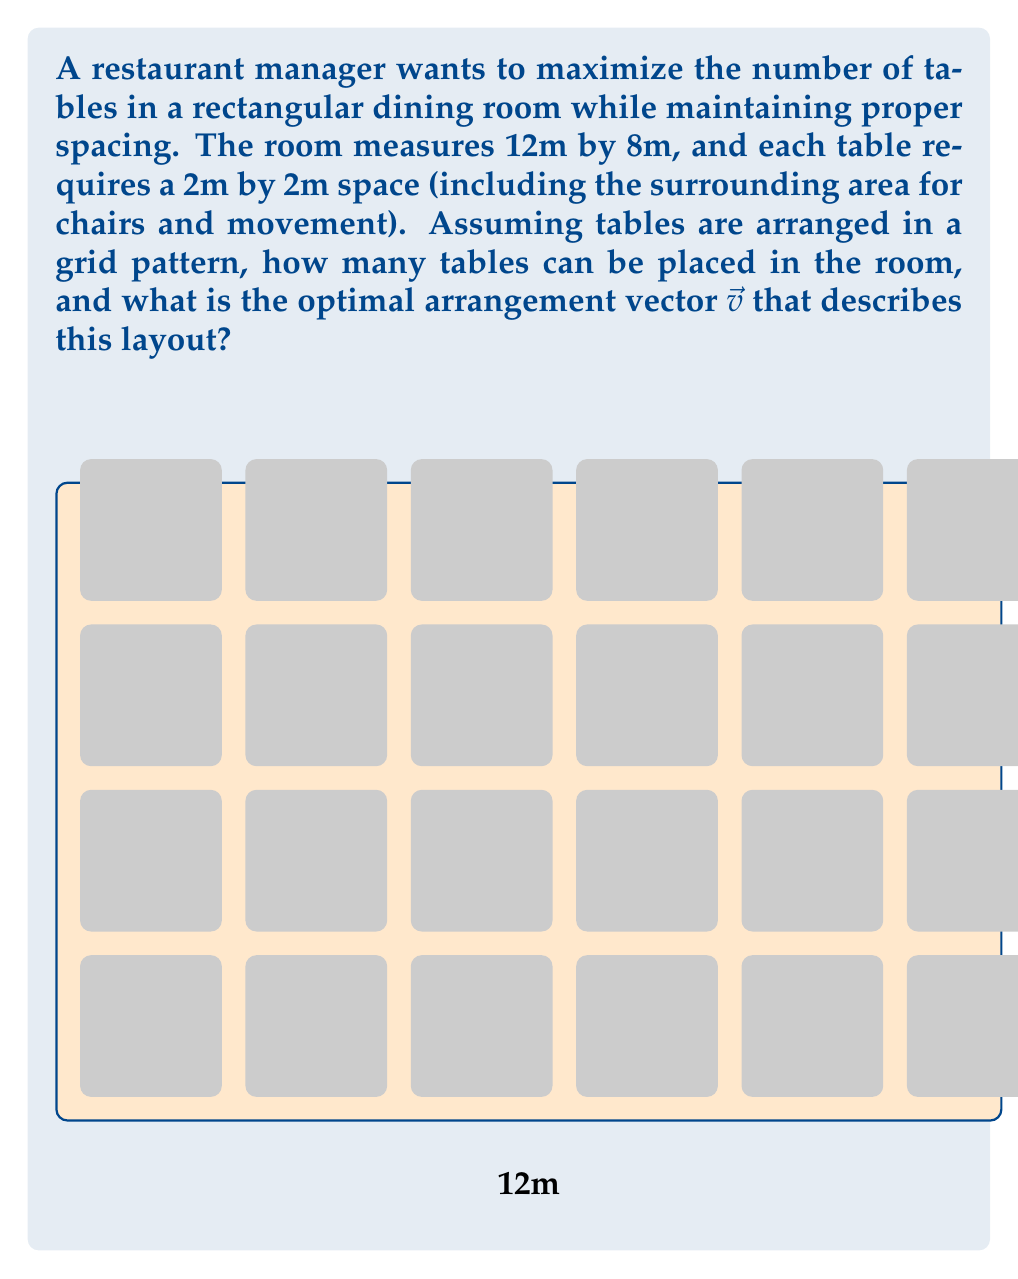Could you help me with this problem? Let's approach this step-by-step:

1) First, we need to determine how many tables can fit along each dimension:

   - Along the 12m side: $12 \div 2 = 6$ tables
   - Along the 8m side: $8 \div 2 = 4$ tables

2) The total number of tables that can fit is therefore:

   $6 \times 4 = 24$ tables

3) Now, to describe this arrangement as a vector, we need to consider how the tables are positioned relative to each other. In this case, we're looking for a vector that, when repeatedly applied, will generate the positions of all tables.

4) The vector should represent the distance between adjacent tables in both dimensions. Since each table (including its surrounding space) is 2m by 2m, our vector will be:

   $\vec{v} = \begin{pmatrix} 2 \\ 2 \end{pmatrix}$

5) This vector $\vec{v}$ represents the step from one table to the next, either horizontally or vertically. By applying this vector repeatedly (up to 5 times horizontally and 3 times vertically), we can generate the positions of all 24 tables.

6) The arrangement can be described by the equation:

   $\text{Table Position} = i\vec{v} + j\vec{v}$

   Where $i = 0, 1, 2, 3, 4, 5$ and $j = 0, 1, 2, 3$

This vector efficiently describes the optimal arrangement of tables in the given dining room space.
Answer: 24 tables; $\vec{v} = \begin{pmatrix} 2 \\ 2 \end{pmatrix}$ 